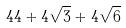<formula> <loc_0><loc_0><loc_500><loc_500>4 4 + 4 \sqrt { 3 } + 4 \sqrt { 6 }</formula> 